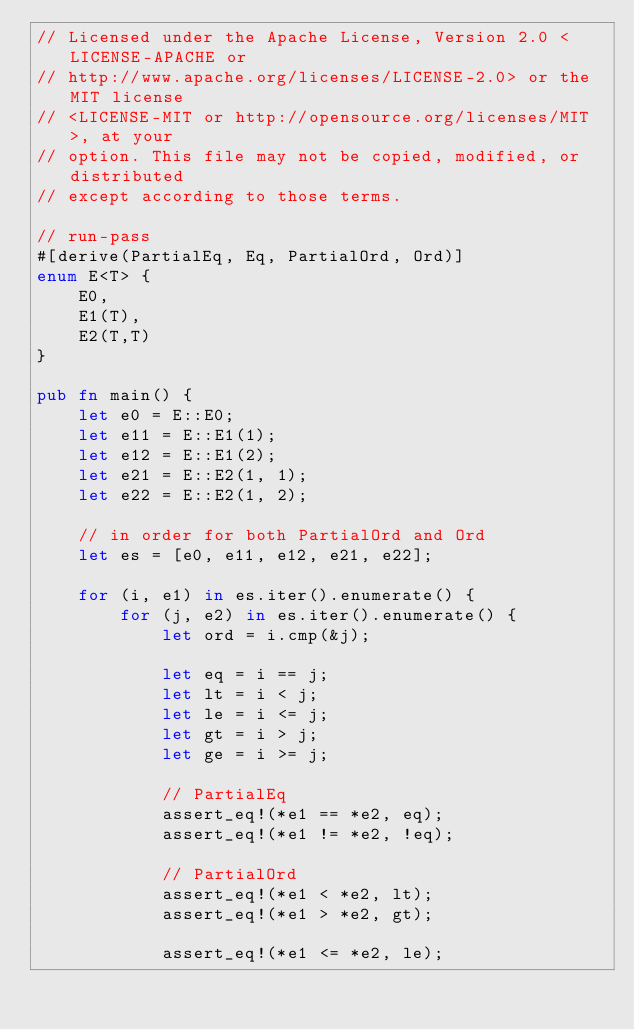Convert code to text. <code><loc_0><loc_0><loc_500><loc_500><_Rust_>// Licensed under the Apache License, Version 2.0 <LICENSE-APACHE or
// http://www.apache.org/licenses/LICENSE-2.0> or the MIT license
// <LICENSE-MIT or http://opensource.org/licenses/MIT>, at your
// option. This file may not be copied, modified, or distributed
// except according to those terms.

// run-pass
#[derive(PartialEq, Eq, PartialOrd, Ord)]
enum E<T> {
    E0,
    E1(T),
    E2(T,T)
}

pub fn main() {
    let e0 = E::E0;
    let e11 = E::E1(1);
    let e12 = E::E1(2);
    let e21 = E::E2(1, 1);
    let e22 = E::E2(1, 2);

    // in order for both PartialOrd and Ord
    let es = [e0, e11, e12, e21, e22];

    for (i, e1) in es.iter().enumerate() {
        for (j, e2) in es.iter().enumerate() {
            let ord = i.cmp(&j);

            let eq = i == j;
            let lt = i < j;
            let le = i <= j;
            let gt = i > j;
            let ge = i >= j;

            // PartialEq
            assert_eq!(*e1 == *e2, eq);
            assert_eq!(*e1 != *e2, !eq);

            // PartialOrd
            assert_eq!(*e1 < *e2, lt);
            assert_eq!(*e1 > *e2, gt);

            assert_eq!(*e1 <= *e2, le);</code> 